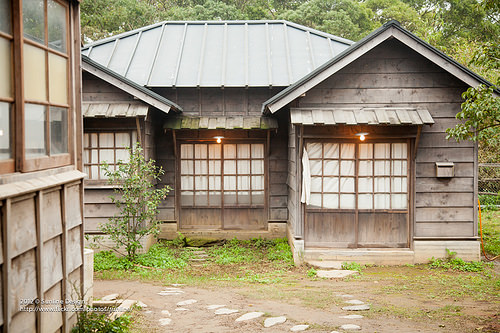<image>
Is there a tree behind the building? Yes. From this viewpoint, the tree is positioned behind the building, with the building partially or fully occluding the tree. 